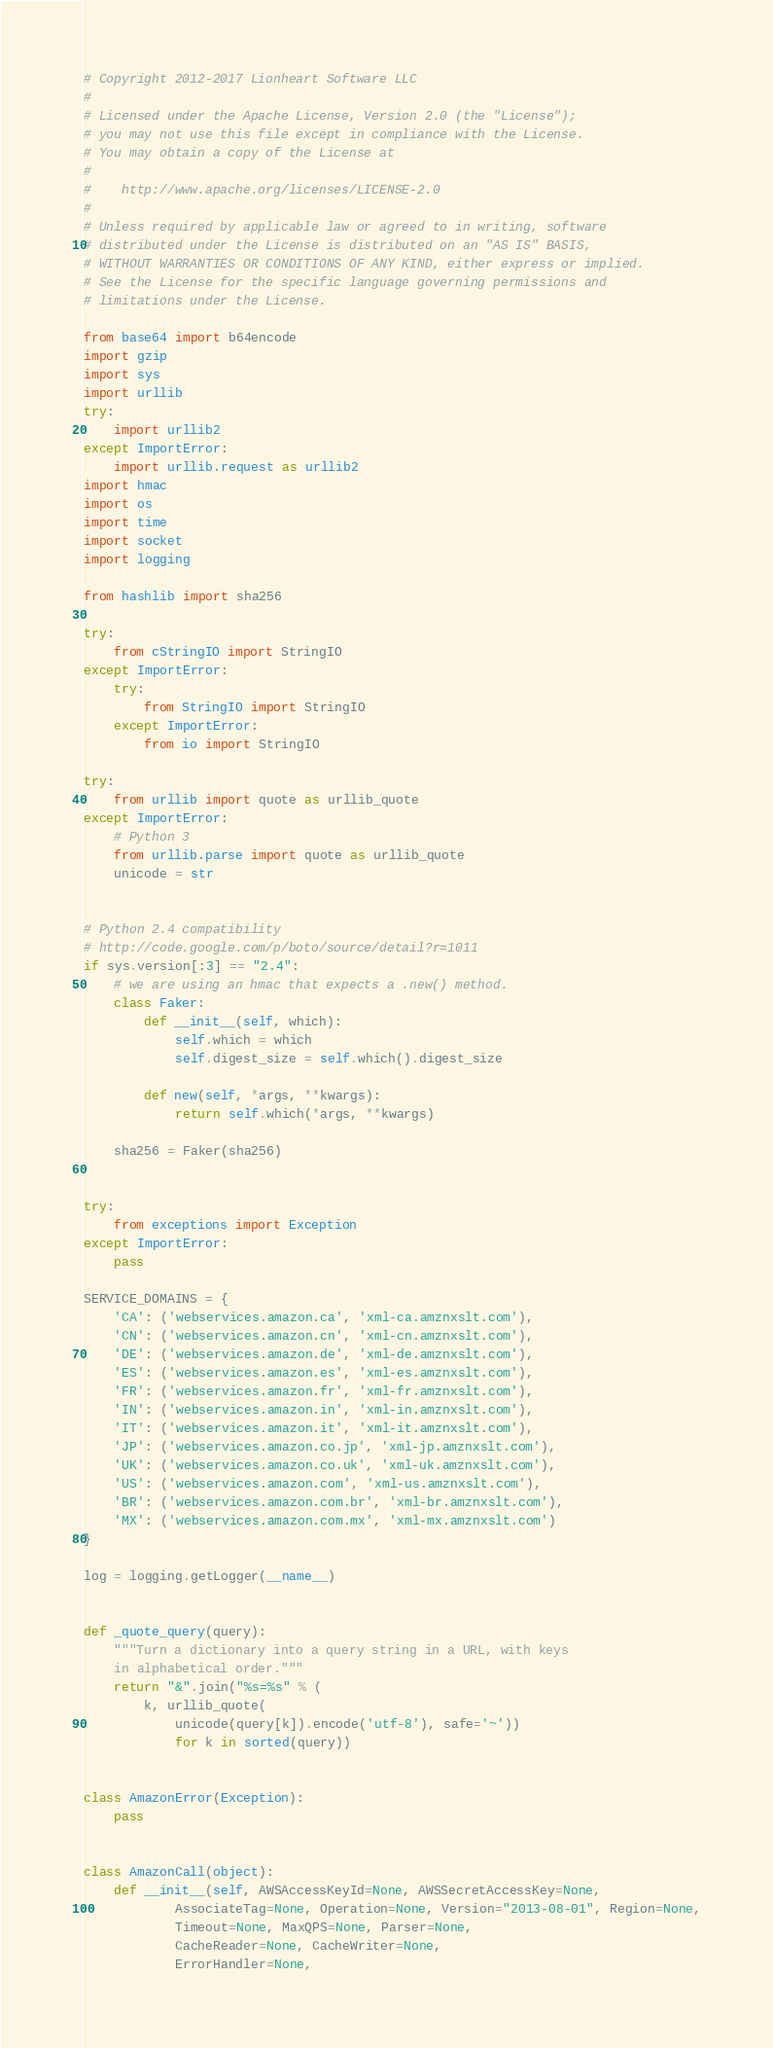<code> <loc_0><loc_0><loc_500><loc_500><_Python_># Copyright 2012-2017 Lionheart Software LLC
#
# Licensed under the Apache License, Version 2.0 (the "License");
# you may not use this file except in compliance with the License.
# You may obtain a copy of the License at
#
#    http://www.apache.org/licenses/LICENSE-2.0
#
# Unless required by applicable law or agreed to in writing, software
# distributed under the License is distributed on an "AS IS" BASIS,
# WITHOUT WARRANTIES OR CONDITIONS OF ANY KIND, either express or implied.
# See the License for the specific language governing permissions and
# limitations under the License.

from base64 import b64encode
import gzip
import sys
import urllib
try:
    import urllib2
except ImportError:
    import urllib.request as urllib2
import hmac
import os
import time
import socket
import logging

from hashlib import sha256

try:
    from cStringIO import StringIO
except ImportError:
    try:
        from StringIO import StringIO
    except ImportError:
        from io import StringIO

try:
    from urllib import quote as urllib_quote
except ImportError:
    # Python 3
    from urllib.parse import quote as urllib_quote
    unicode = str


# Python 2.4 compatibility
# http://code.google.com/p/boto/source/detail?r=1011
if sys.version[:3] == "2.4":
    # we are using an hmac that expects a .new() method.
    class Faker:
        def __init__(self, which):
            self.which = which
            self.digest_size = self.which().digest_size

        def new(self, *args, **kwargs):
            return self.which(*args, **kwargs)

    sha256 = Faker(sha256)


try:
    from exceptions import Exception
except ImportError:
    pass

SERVICE_DOMAINS = {
    'CA': ('webservices.amazon.ca', 'xml-ca.amznxslt.com'),
    'CN': ('webservices.amazon.cn', 'xml-cn.amznxslt.com'),
    'DE': ('webservices.amazon.de', 'xml-de.amznxslt.com'),
    'ES': ('webservices.amazon.es', 'xml-es.amznxslt.com'),
    'FR': ('webservices.amazon.fr', 'xml-fr.amznxslt.com'),
    'IN': ('webservices.amazon.in', 'xml-in.amznxslt.com'),
    'IT': ('webservices.amazon.it', 'xml-it.amznxslt.com'),
    'JP': ('webservices.amazon.co.jp', 'xml-jp.amznxslt.com'),
    'UK': ('webservices.amazon.co.uk', 'xml-uk.amznxslt.com'),
    'US': ('webservices.amazon.com', 'xml-us.amznxslt.com'),
    'BR': ('webservices.amazon.com.br', 'xml-br.amznxslt.com'),
    'MX': ('webservices.amazon.com.mx', 'xml-mx.amznxslt.com')
}

log = logging.getLogger(__name__)


def _quote_query(query):
    """Turn a dictionary into a query string in a URL, with keys
    in alphabetical order."""
    return "&".join("%s=%s" % (
        k, urllib_quote(
            unicode(query[k]).encode('utf-8'), safe='~'))
            for k in sorted(query))


class AmazonError(Exception):
    pass


class AmazonCall(object):
    def __init__(self, AWSAccessKeyId=None, AWSSecretAccessKey=None,
            AssociateTag=None, Operation=None, Version="2013-08-01", Region=None,
            Timeout=None, MaxQPS=None, Parser=None,
            CacheReader=None, CacheWriter=None,
            ErrorHandler=None,</code> 